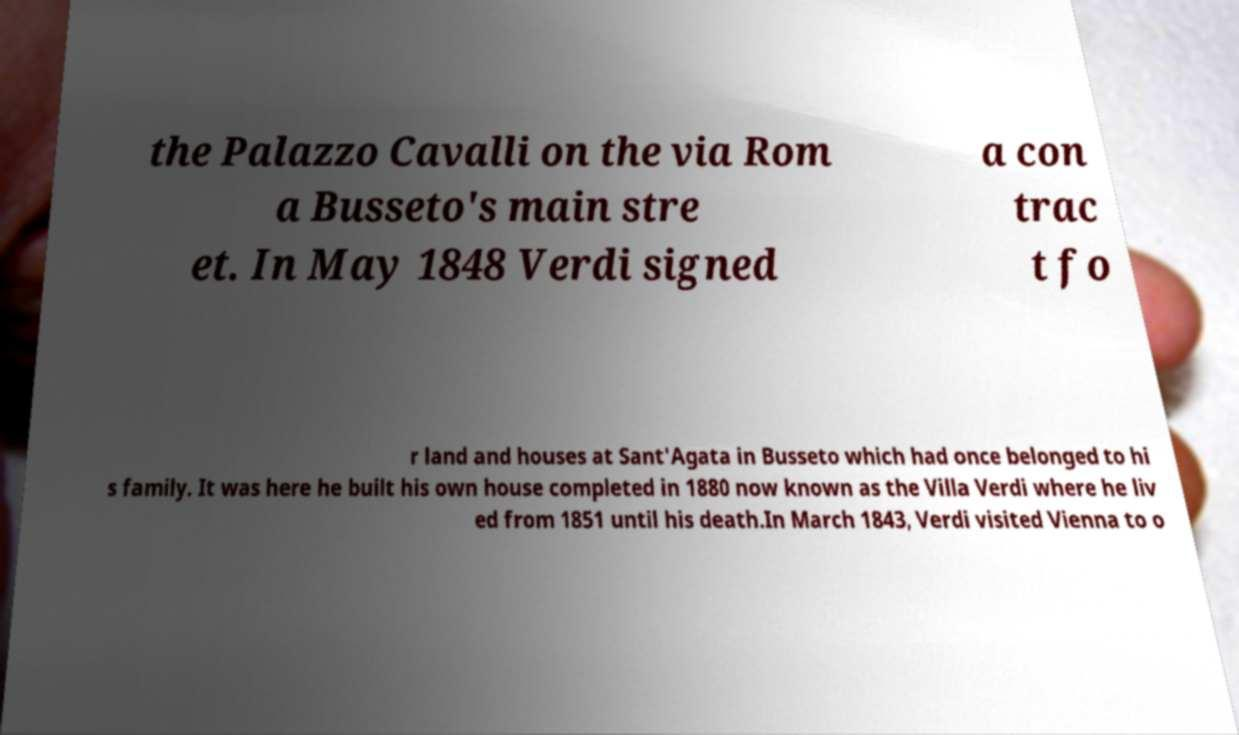Could you assist in decoding the text presented in this image and type it out clearly? the Palazzo Cavalli on the via Rom a Busseto's main stre et. In May 1848 Verdi signed a con trac t fo r land and houses at Sant'Agata in Busseto which had once belonged to hi s family. It was here he built his own house completed in 1880 now known as the Villa Verdi where he liv ed from 1851 until his death.In March 1843, Verdi visited Vienna to o 